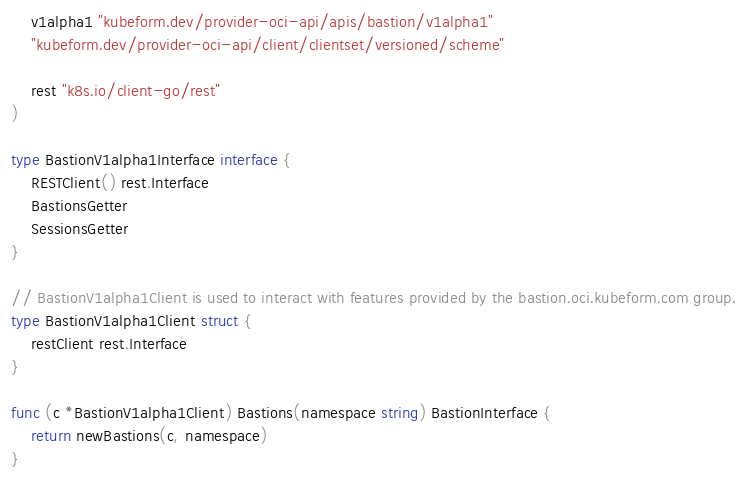Convert code to text. <code><loc_0><loc_0><loc_500><loc_500><_Go_>	v1alpha1 "kubeform.dev/provider-oci-api/apis/bastion/v1alpha1"
	"kubeform.dev/provider-oci-api/client/clientset/versioned/scheme"

	rest "k8s.io/client-go/rest"
)

type BastionV1alpha1Interface interface {
	RESTClient() rest.Interface
	BastionsGetter
	SessionsGetter
}

// BastionV1alpha1Client is used to interact with features provided by the bastion.oci.kubeform.com group.
type BastionV1alpha1Client struct {
	restClient rest.Interface
}

func (c *BastionV1alpha1Client) Bastions(namespace string) BastionInterface {
	return newBastions(c, namespace)
}
</code> 